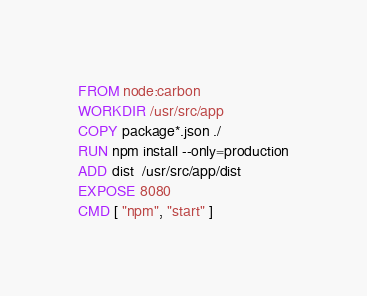<code> <loc_0><loc_0><loc_500><loc_500><_Dockerfile_>FROM node:carbon
WORKDIR /usr/src/app
COPY package*.json ./
RUN npm install --only=production
ADD dist  /usr/src/app/dist
EXPOSE 8080
CMD [ "npm", "start" ]</code> 